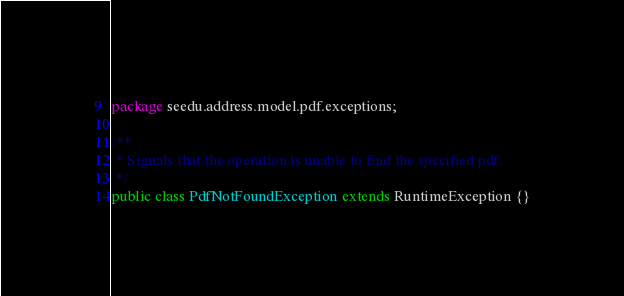Convert code to text. <code><loc_0><loc_0><loc_500><loc_500><_Java_>package seedu.address.model.pdf.exceptions;

/**
 * Signals that the operation is unable to find the specified pdf.
 */
public class PdfNotFoundException extends RuntimeException {}
</code> 